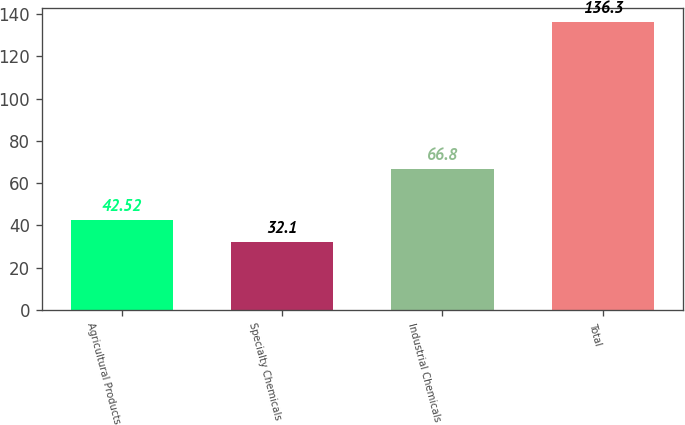Convert chart to OTSL. <chart><loc_0><loc_0><loc_500><loc_500><bar_chart><fcel>Agricultural Products<fcel>Specialty Chemicals<fcel>Industrial Chemicals<fcel>Total<nl><fcel>42.52<fcel>32.1<fcel>66.8<fcel>136.3<nl></chart> 